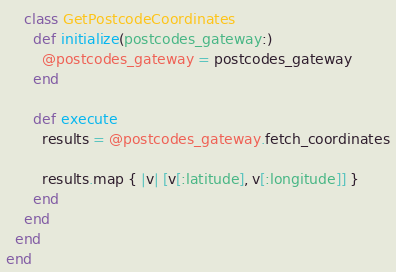Convert code to text. <code><loc_0><loc_0><loc_500><loc_500><_Ruby_>    class GetPostcodeCoordinates
      def initialize(postcodes_gateway:)
        @postcodes_gateway = postcodes_gateway
      end

      def execute
        results = @postcodes_gateway.fetch_coordinates

        results.map { |v| [v[:latitude], v[:longitude]] }
      end
    end
  end
end
</code> 